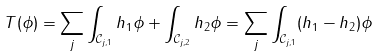Convert formula to latex. <formula><loc_0><loc_0><loc_500><loc_500>T ( \phi ) = \sum _ { j } \int _ { \mathcal { C } _ { j , 1 } } h _ { 1 } \phi + \int _ { \mathcal { C } _ { j , 2 } } h _ { 2 } \phi = \sum _ { j } \int _ { \mathcal { C } _ { j , 1 } } ( h _ { 1 } - h _ { 2 } ) \phi</formula> 